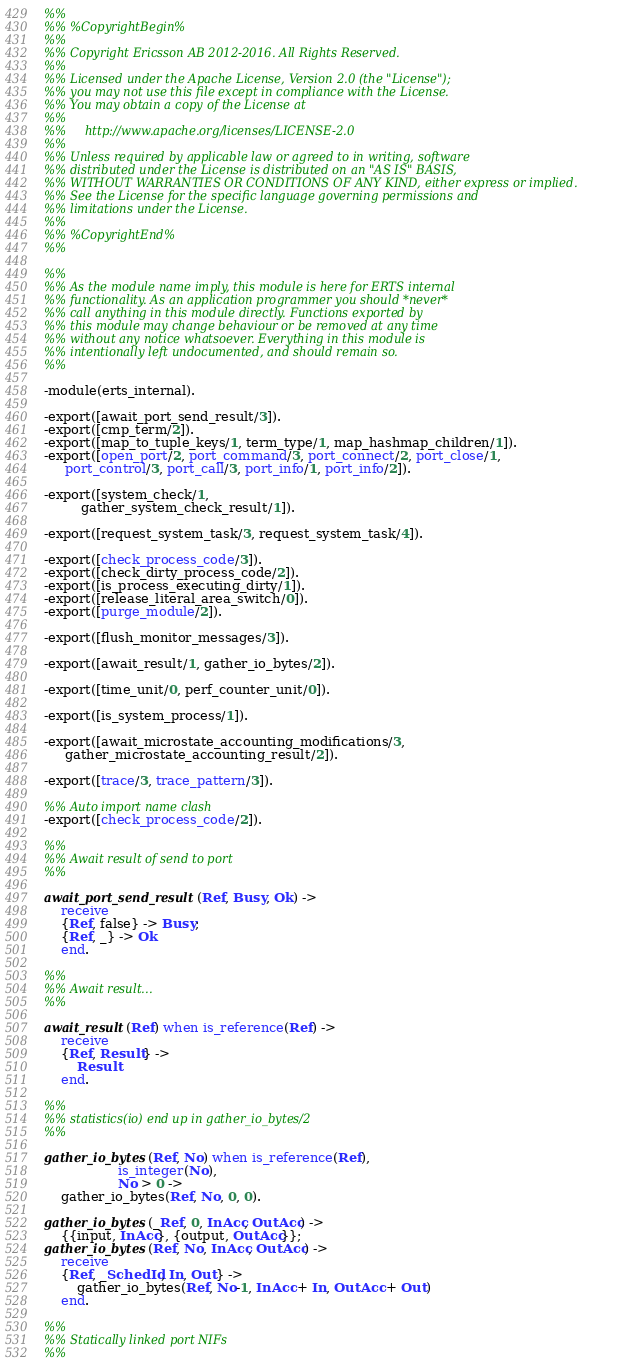<code> <loc_0><loc_0><loc_500><loc_500><_Erlang_>%%
%% %CopyrightBegin%
%%
%% Copyright Ericsson AB 2012-2016. All Rights Reserved.
%%
%% Licensed under the Apache License, Version 2.0 (the "License");
%% you may not use this file except in compliance with the License.
%% You may obtain a copy of the License at
%%
%%     http://www.apache.org/licenses/LICENSE-2.0
%%
%% Unless required by applicable law or agreed to in writing, software
%% distributed under the License is distributed on an "AS IS" BASIS,
%% WITHOUT WARRANTIES OR CONDITIONS OF ANY KIND, either express or implied.
%% See the License for the specific language governing permissions and
%% limitations under the License.
%%
%% %CopyrightEnd%
%%

%%
%% As the module name imply, this module is here for ERTS internal
%% functionality. As an application programmer you should *never*
%% call anything in this module directly. Functions exported by
%% this module may change behaviour or be removed at any time
%% without any notice whatsoever. Everything in this module is
%% intentionally left undocumented, and should remain so.
%%

-module(erts_internal).

-export([await_port_send_result/3]).
-export([cmp_term/2]).
-export([map_to_tuple_keys/1, term_type/1, map_hashmap_children/1]).
-export([open_port/2, port_command/3, port_connect/2, port_close/1,
	 port_control/3, port_call/3, port_info/1, port_info/2]).

-export([system_check/1,
         gather_system_check_result/1]).

-export([request_system_task/3, request_system_task/4]).

-export([check_process_code/3]).
-export([check_dirty_process_code/2]).
-export([is_process_executing_dirty/1]).
-export([release_literal_area_switch/0]).
-export([purge_module/2]).

-export([flush_monitor_messages/3]).

-export([await_result/1, gather_io_bytes/2]).

-export([time_unit/0, perf_counter_unit/0]).

-export([is_system_process/1]).

-export([await_microstate_accounting_modifications/3,
	 gather_microstate_accounting_result/2]).

-export([trace/3, trace_pattern/3]).

%% Auto import name clash
-export([check_process_code/2]).

%%
%% Await result of send to port
%%

await_port_send_result(Ref, Busy, Ok) ->
    receive
	{Ref, false} -> Busy;
	{Ref, _} -> Ok
    end.

%%
%% Await result...
%%

await_result(Ref) when is_reference(Ref) ->
    receive
	{Ref, Result} ->
	    Result
    end.

%%
%% statistics(io) end up in gather_io_bytes/2
%%

gather_io_bytes(Ref, No) when is_reference(Ref),
			      is_integer(No),
			      No > 0 ->
    gather_io_bytes(Ref, No, 0, 0).

gather_io_bytes(_Ref, 0, InAcc, OutAcc) ->
    {{input, InAcc}, {output, OutAcc}};
gather_io_bytes(Ref, No, InAcc, OutAcc) ->
    receive
	{Ref, _SchedId, In, Out} ->
	    gather_io_bytes(Ref, No-1, InAcc + In, OutAcc + Out)
    end.

%%
%% Statically linked port NIFs
%%
</code> 